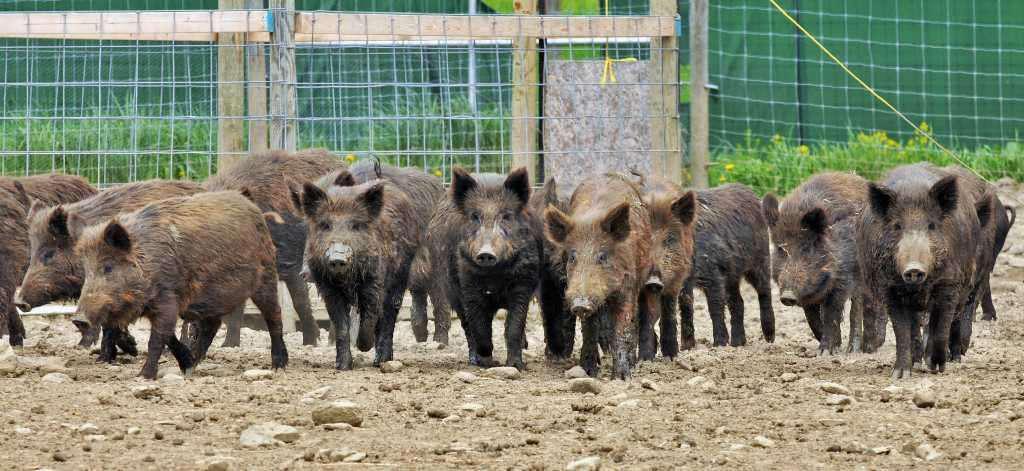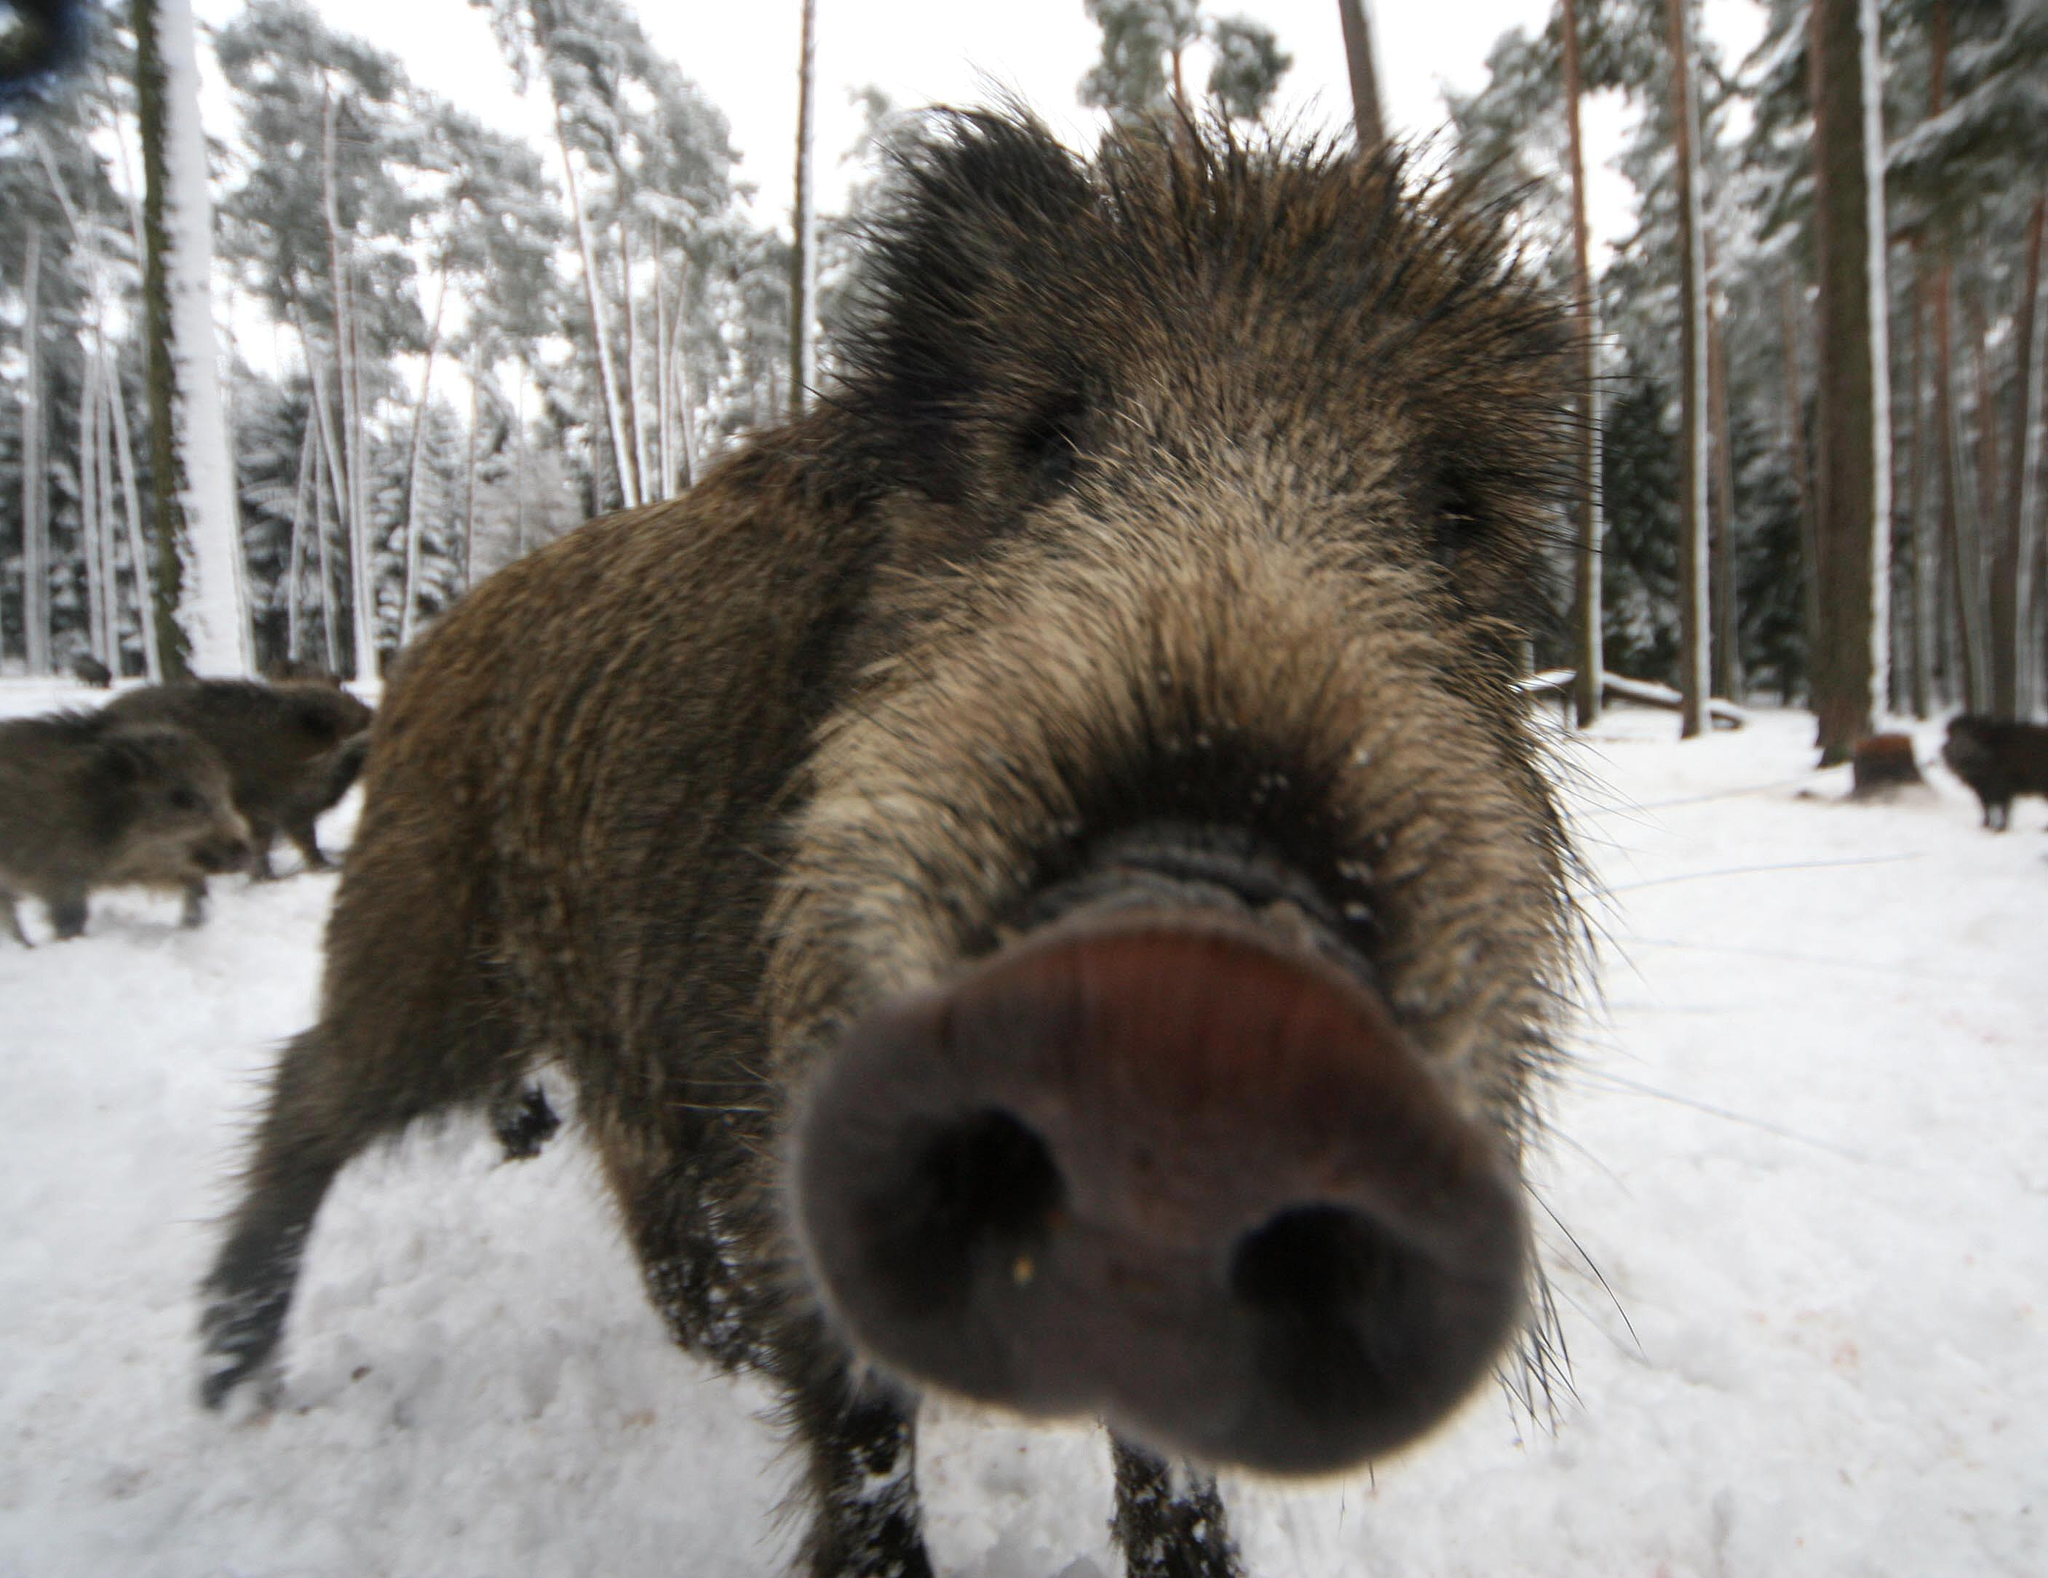The first image is the image on the left, the second image is the image on the right. Examine the images to the left and right. Is the description "An image contains one wild pig in the foreground with its body turned forward, in an area with snow covering the ground." accurate? Answer yes or no. Yes. The first image is the image on the left, the second image is the image on the right. For the images shown, is this caption "Only one image has animals in the snow." true? Answer yes or no. Yes. 